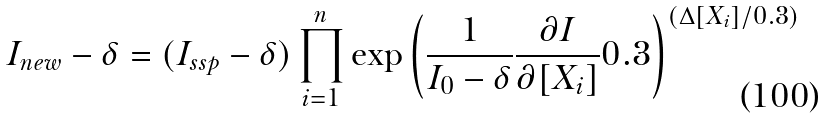Convert formula to latex. <formula><loc_0><loc_0><loc_500><loc_500>I _ { n e w } - \delta = ( I _ { s s p } - \delta ) \prod ^ { n } _ { i = 1 } \exp \left ( \frac { 1 } { I _ { 0 } - \delta } \frac { \partial I } { \partial [ X _ { i } ] } 0 . 3 \right ) ^ { ( \Delta [ X _ { i } ] / 0 . 3 ) }</formula> 